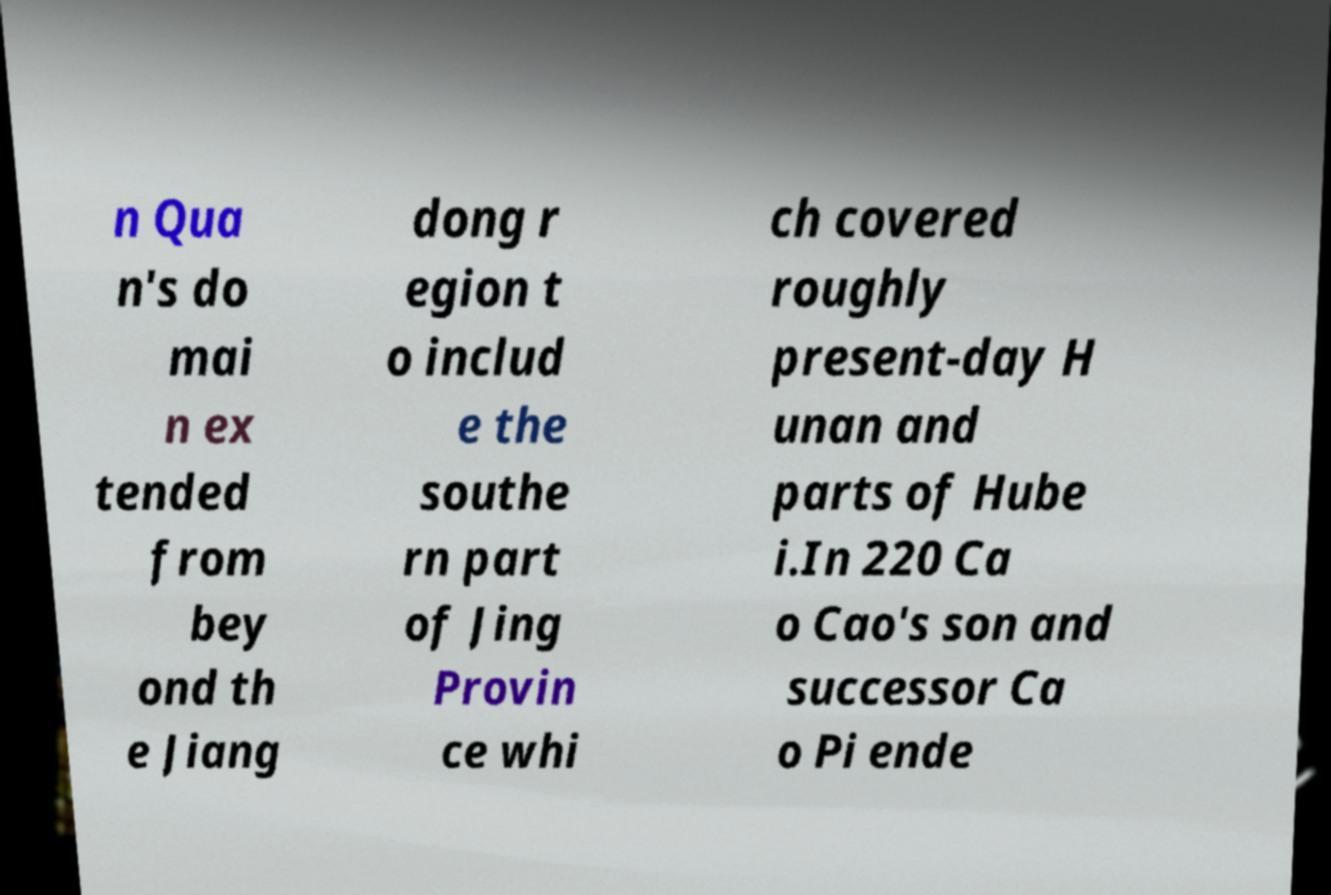For documentation purposes, I need the text within this image transcribed. Could you provide that? n Qua n's do mai n ex tended from bey ond th e Jiang dong r egion t o includ e the southe rn part of Jing Provin ce whi ch covered roughly present-day H unan and parts of Hube i.In 220 Ca o Cao's son and successor Ca o Pi ende 